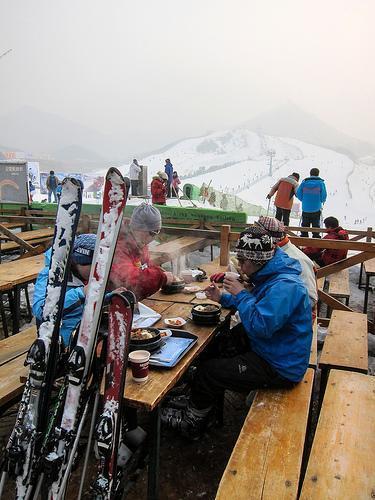How many pairs of skis are leaning against the table?
Give a very brief answer. 3. 